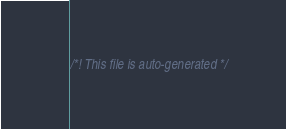<code> <loc_0><loc_0><loc_500><loc_500><_CSS_>/*! This file is auto-generated */</code> 